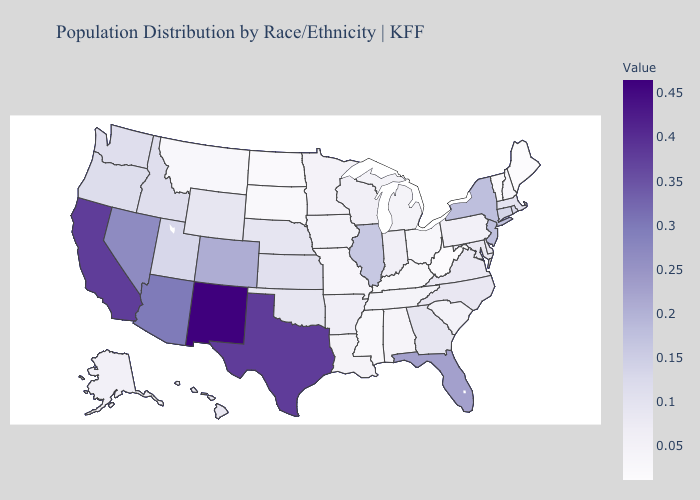Does Washington have a lower value than Vermont?
Answer briefly. No. Does Idaho have a higher value than Mississippi?
Answer briefly. Yes. 